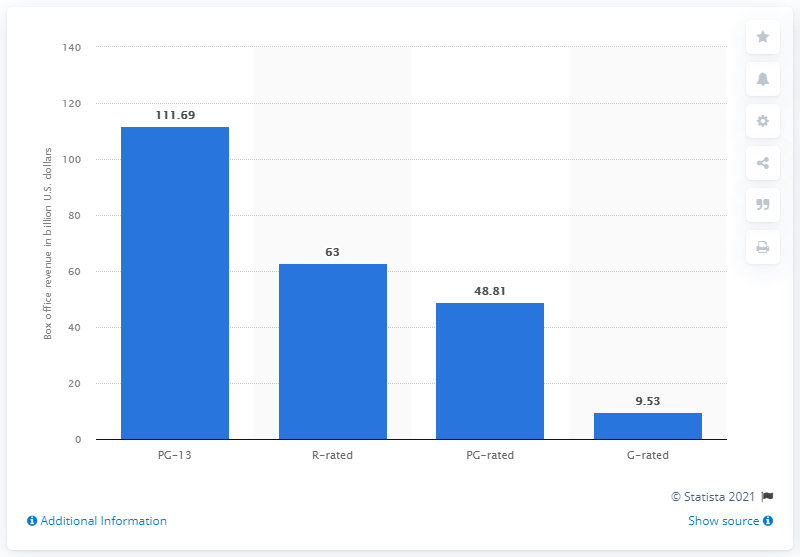Give some essential details in this illustration. As of May 2021, the total box office of PG-13 movies was 111.69. The amount of money that R-rated movies brought in during the measured period is 63. The highest-rated movie in the United States in 2021 that has been rated PG-13 is... 